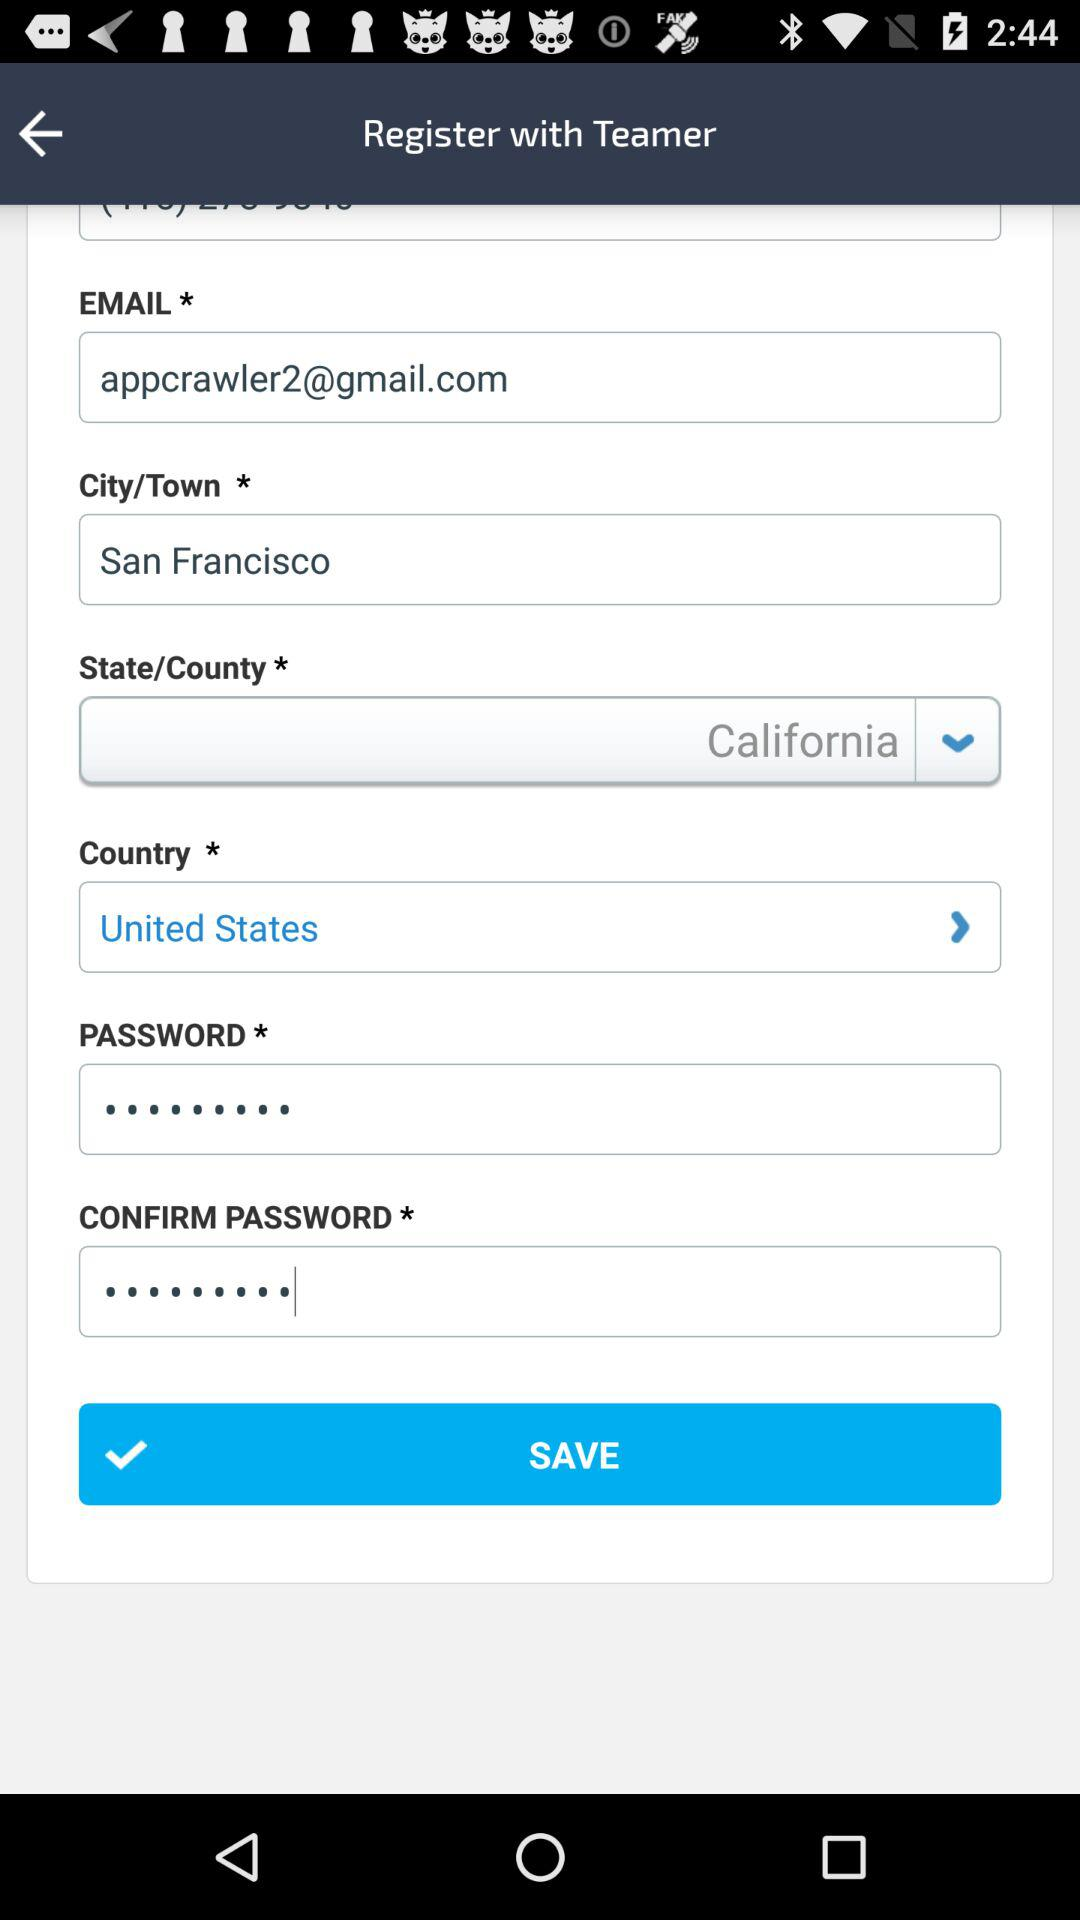Which state and country are selected to register? The selected state and country are California and the United States. 